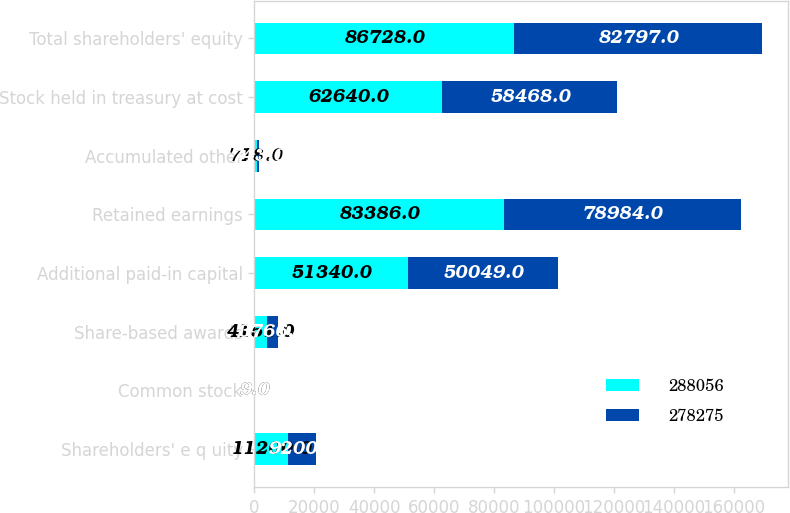<chart> <loc_0><loc_0><loc_500><loc_500><stacked_bar_chart><ecel><fcel>Shareholders' e q uity<fcel>Common stock<fcel>Share-based awards<fcel>Additional paid-in capital<fcel>Retained earnings<fcel>Accumulated other<fcel>Stock held in treasury at cost<fcel>Total shareholders' equity<nl><fcel>288056<fcel>11200<fcel>9<fcel>4151<fcel>51340<fcel>83386<fcel>718<fcel>62640<fcel>86728<nl><fcel>278275<fcel>9200<fcel>9<fcel>3766<fcel>50049<fcel>78984<fcel>743<fcel>58468<fcel>82797<nl></chart> 